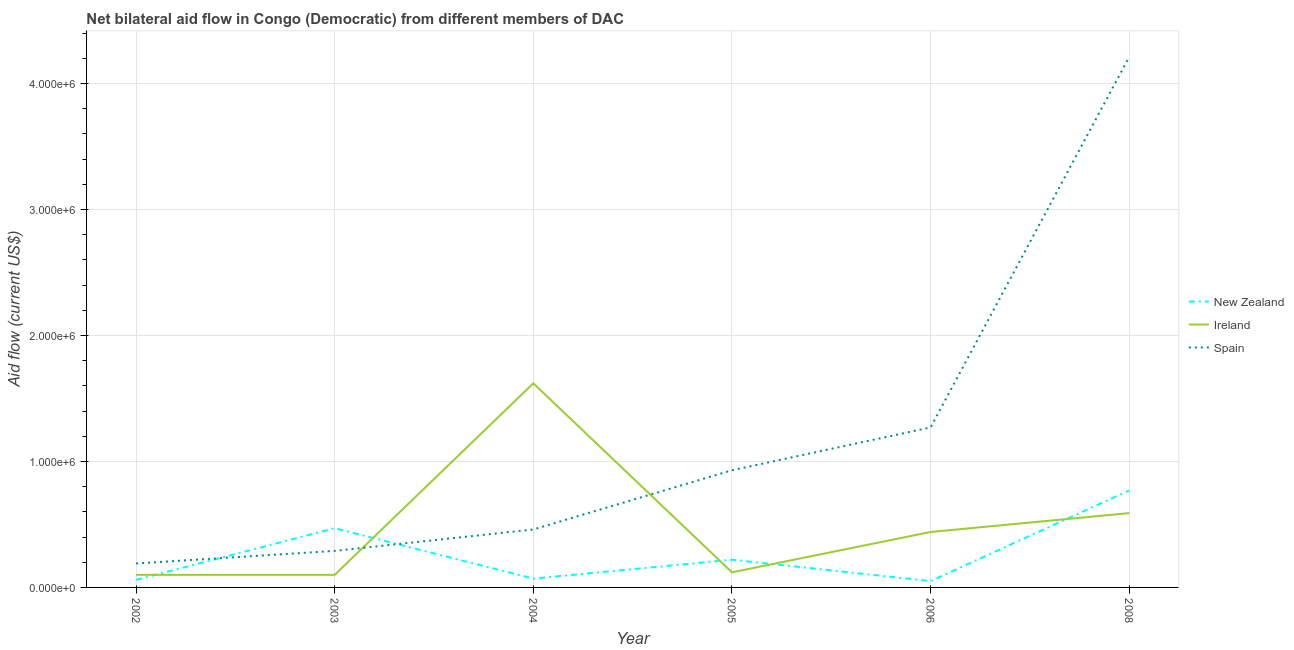Is the number of lines equal to the number of legend labels?
Your answer should be very brief. Yes. What is the amount of aid provided by ireland in 2006?
Offer a terse response. 4.40e+05. Across all years, what is the maximum amount of aid provided by ireland?
Provide a succinct answer. 1.62e+06. Across all years, what is the minimum amount of aid provided by spain?
Your answer should be compact. 1.90e+05. In which year was the amount of aid provided by spain maximum?
Provide a short and direct response. 2008. In which year was the amount of aid provided by spain minimum?
Keep it short and to the point. 2002. What is the total amount of aid provided by spain in the graph?
Your answer should be very brief. 7.35e+06. What is the difference between the amount of aid provided by ireland in 2002 and that in 2003?
Offer a very short reply. 0. What is the difference between the amount of aid provided by ireland in 2005 and the amount of aid provided by new zealand in 2003?
Provide a short and direct response. -3.50e+05. What is the average amount of aid provided by new zealand per year?
Your response must be concise. 2.73e+05. In the year 2002, what is the difference between the amount of aid provided by spain and amount of aid provided by ireland?
Keep it short and to the point. 9.00e+04. What is the ratio of the amount of aid provided by new zealand in 2002 to that in 2004?
Make the answer very short. 0.86. Is the amount of aid provided by ireland in 2004 less than that in 2008?
Give a very brief answer. No. Is the difference between the amount of aid provided by new zealand in 2003 and 2006 greater than the difference between the amount of aid provided by ireland in 2003 and 2006?
Your answer should be very brief. Yes. What is the difference between the highest and the second highest amount of aid provided by ireland?
Your response must be concise. 1.03e+06. What is the difference between the highest and the lowest amount of aid provided by spain?
Your answer should be very brief. 4.02e+06. Is the sum of the amount of aid provided by new zealand in 2005 and 2008 greater than the maximum amount of aid provided by spain across all years?
Offer a terse response. No. Is it the case that in every year, the sum of the amount of aid provided by new zealand and amount of aid provided by ireland is greater than the amount of aid provided by spain?
Offer a very short reply. No. Does the amount of aid provided by spain monotonically increase over the years?
Your response must be concise. Yes. Is the amount of aid provided by spain strictly less than the amount of aid provided by ireland over the years?
Your answer should be compact. No. How many years are there in the graph?
Make the answer very short. 6. What is the difference between two consecutive major ticks on the Y-axis?
Your answer should be very brief. 1.00e+06. Does the graph contain grids?
Your answer should be very brief. Yes. What is the title of the graph?
Provide a short and direct response. Net bilateral aid flow in Congo (Democratic) from different members of DAC. Does "Ages 50+" appear as one of the legend labels in the graph?
Your answer should be very brief. No. What is the label or title of the X-axis?
Give a very brief answer. Year. What is the label or title of the Y-axis?
Make the answer very short. Aid flow (current US$). What is the Aid flow (current US$) in New Zealand in 2002?
Provide a succinct answer. 6.00e+04. What is the Aid flow (current US$) of Ireland in 2002?
Provide a succinct answer. 1.00e+05. What is the Aid flow (current US$) of New Zealand in 2003?
Your answer should be very brief. 4.70e+05. What is the Aid flow (current US$) in Ireland in 2003?
Ensure brevity in your answer.  1.00e+05. What is the Aid flow (current US$) of Spain in 2003?
Provide a short and direct response. 2.90e+05. What is the Aid flow (current US$) of Ireland in 2004?
Your answer should be compact. 1.62e+06. What is the Aid flow (current US$) of Spain in 2005?
Your response must be concise. 9.30e+05. What is the Aid flow (current US$) of Spain in 2006?
Offer a very short reply. 1.27e+06. What is the Aid flow (current US$) of New Zealand in 2008?
Offer a very short reply. 7.70e+05. What is the Aid flow (current US$) in Ireland in 2008?
Your response must be concise. 5.90e+05. What is the Aid flow (current US$) of Spain in 2008?
Provide a short and direct response. 4.21e+06. Across all years, what is the maximum Aid flow (current US$) in New Zealand?
Offer a terse response. 7.70e+05. Across all years, what is the maximum Aid flow (current US$) of Ireland?
Your answer should be compact. 1.62e+06. Across all years, what is the maximum Aid flow (current US$) of Spain?
Ensure brevity in your answer.  4.21e+06. Across all years, what is the minimum Aid flow (current US$) of New Zealand?
Give a very brief answer. 5.00e+04. Across all years, what is the minimum Aid flow (current US$) in Ireland?
Your answer should be very brief. 1.00e+05. What is the total Aid flow (current US$) in New Zealand in the graph?
Ensure brevity in your answer.  1.64e+06. What is the total Aid flow (current US$) in Ireland in the graph?
Your answer should be compact. 2.97e+06. What is the total Aid flow (current US$) of Spain in the graph?
Provide a short and direct response. 7.35e+06. What is the difference between the Aid flow (current US$) of New Zealand in 2002 and that in 2003?
Give a very brief answer. -4.10e+05. What is the difference between the Aid flow (current US$) of Ireland in 2002 and that in 2003?
Your response must be concise. 0. What is the difference between the Aid flow (current US$) of Spain in 2002 and that in 2003?
Keep it short and to the point. -1.00e+05. What is the difference between the Aid flow (current US$) in New Zealand in 2002 and that in 2004?
Offer a very short reply. -10000. What is the difference between the Aid flow (current US$) of Ireland in 2002 and that in 2004?
Keep it short and to the point. -1.52e+06. What is the difference between the Aid flow (current US$) of New Zealand in 2002 and that in 2005?
Offer a very short reply. -1.60e+05. What is the difference between the Aid flow (current US$) of Spain in 2002 and that in 2005?
Your response must be concise. -7.40e+05. What is the difference between the Aid flow (current US$) in New Zealand in 2002 and that in 2006?
Your answer should be very brief. 10000. What is the difference between the Aid flow (current US$) in Ireland in 2002 and that in 2006?
Your answer should be very brief. -3.40e+05. What is the difference between the Aid flow (current US$) of Spain in 2002 and that in 2006?
Provide a short and direct response. -1.08e+06. What is the difference between the Aid flow (current US$) in New Zealand in 2002 and that in 2008?
Provide a succinct answer. -7.10e+05. What is the difference between the Aid flow (current US$) in Ireland in 2002 and that in 2008?
Your response must be concise. -4.90e+05. What is the difference between the Aid flow (current US$) of Spain in 2002 and that in 2008?
Your answer should be compact. -4.02e+06. What is the difference between the Aid flow (current US$) in New Zealand in 2003 and that in 2004?
Your answer should be very brief. 4.00e+05. What is the difference between the Aid flow (current US$) in Ireland in 2003 and that in 2004?
Ensure brevity in your answer.  -1.52e+06. What is the difference between the Aid flow (current US$) in New Zealand in 2003 and that in 2005?
Keep it short and to the point. 2.50e+05. What is the difference between the Aid flow (current US$) in Spain in 2003 and that in 2005?
Your answer should be very brief. -6.40e+05. What is the difference between the Aid flow (current US$) in New Zealand in 2003 and that in 2006?
Keep it short and to the point. 4.20e+05. What is the difference between the Aid flow (current US$) of Ireland in 2003 and that in 2006?
Your answer should be compact. -3.40e+05. What is the difference between the Aid flow (current US$) of Spain in 2003 and that in 2006?
Offer a terse response. -9.80e+05. What is the difference between the Aid flow (current US$) in New Zealand in 2003 and that in 2008?
Your response must be concise. -3.00e+05. What is the difference between the Aid flow (current US$) in Ireland in 2003 and that in 2008?
Your answer should be very brief. -4.90e+05. What is the difference between the Aid flow (current US$) of Spain in 2003 and that in 2008?
Ensure brevity in your answer.  -3.92e+06. What is the difference between the Aid flow (current US$) in New Zealand in 2004 and that in 2005?
Make the answer very short. -1.50e+05. What is the difference between the Aid flow (current US$) of Ireland in 2004 and that in 2005?
Ensure brevity in your answer.  1.50e+06. What is the difference between the Aid flow (current US$) in Spain in 2004 and that in 2005?
Provide a succinct answer. -4.70e+05. What is the difference between the Aid flow (current US$) in New Zealand in 2004 and that in 2006?
Ensure brevity in your answer.  2.00e+04. What is the difference between the Aid flow (current US$) of Ireland in 2004 and that in 2006?
Offer a very short reply. 1.18e+06. What is the difference between the Aid flow (current US$) in Spain in 2004 and that in 2006?
Offer a terse response. -8.10e+05. What is the difference between the Aid flow (current US$) of New Zealand in 2004 and that in 2008?
Your response must be concise. -7.00e+05. What is the difference between the Aid flow (current US$) of Ireland in 2004 and that in 2008?
Your response must be concise. 1.03e+06. What is the difference between the Aid flow (current US$) in Spain in 2004 and that in 2008?
Ensure brevity in your answer.  -3.75e+06. What is the difference between the Aid flow (current US$) in New Zealand in 2005 and that in 2006?
Offer a terse response. 1.70e+05. What is the difference between the Aid flow (current US$) of Ireland in 2005 and that in 2006?
Make the answer very short. -3.20e+05. What is the difference between the Aid flow (current US$) in New Zealand in 2005 and that in 2008?
Give a very brief answer. -5.50e+05. What is the difference between the Aid flow (current US$) in Ireland in 2005 and that in 2008?
Give a very brief answer. -4.70e+05. What is the difference between the Aid flow (current US$) in Spain in 2005 and that in 2008?
Provide a succinct answer. -3.28e+06. What is the difference between the Aid flow (current US$) of New Zealand in 2006 and that in 2008?
Your response must be concise. -7.20e+05. What is the difference between the Aid flow (current US$) in Spain in 2006 and that in 2008?
Your response must be concise. -2.94e+06. What is the difference between the Aid flow (current US$) of New Zealand in 2002 and the Aid flow (current US$) of Ireland in 2003?
Make the answer very short. -4.00e+04. What is the difference between the Aid flow (current US$) of Ireland in 2002 and the Aid flow (current US$) of Spain in 2003?
Provide a succinct answer. -1.90e+05. What is the difference between the Aid flow (current US$) of New Zealand in 2002 and the Aid flow (current US$) of Ireland in 2004?
Provide a short and direct response. -1.56e+06. What is the difference between the Aid flow (current US$) in New Zealand in 2002 and the Aid flow (current US$) in Spain in 2004?
Offer a very short reply. -4.00e+05. What is the difference between the Aid flow (current US$) in Ireland in 2002 and the Aid flow (current US$) in Spain in 2004?
Offer a very short reply. -3.60e+05. What is the difference between the Aid flow (current US$) of New Zealand in 2002 and the Aid flow (current US$) of Ireland in 2005?
Your answer should be very brief. -6.00e+04. What is the difference between the Aid flow (current US$) in New Zealand in 2002 and the Aid flow (current US$) in Spain in 2005?
Give a very brief answer. -8.70e+05. What is the difference between the Aid flow (current US$) in Ireland in 2002 and the Aid flow (current US$) in Spain in 2005?
Give a very brief answer. -8.30e+05. What is the difference between the Aid flow (current US$) of New Zealand in 2002 and the Aid flow (current US$) of Ireland in 2006?
Provide a short and direct response. -3.80e+05. What is the difference between the Aid flow (current US$) in New Zealand in 2002 and the Aid flow (current US$) in Spain in 2006?
Your answer should be very brief. -1.21e+06. What is the difference between the Aid flow (current US$) of Ireland in 2002 and the Aid flow (current US$) of Spain in 2006?
Your answer should be very brief. -1.17e+06. What is the difference between the Aid flow (current US$) of New Zealand in 2002 and the Aid flow (current US$) of Ireland in 2008?
Give a very brief answer. -5.30e+05. What is the difference between the Aid flow (current US$) in New Zealand in 2002 and the Aid flow (current US$) in Spain in 2008?
Offer a terse response. -4.15e+06. What is the difference between the Aid flow (current US$) of Ireland in 2002 and the Aid flow (current US$) of Spain in 2008?
Keep it short and to the point. -4.11e+06. What is the difference between the Aid flow (current US$) in New Zealand in 2003 and the Aid flow (current US$) in Ireland in 2004?
Offer a very short reply. -1.15e+06. What is the difference between the Aid flow (current US$) of New Zealand in 2003 and the Aid flow (current US$) of Spain in 2004?
Offer a very short reply. 10000. What is the difference between the Aid flow (current US$) in Ireland in 2003 and the Aid flow (current US$) in Spain in 2004?
Provide a succinct answer. -3.60e+05. What is the difference between the Aid flow (current US$) in New Zealand in 2003 and the Aid flow (current US$) in Ireland in 2005?
Make the answer very short. 3.50e+05. What is the difference between the Aid flow (current US$) in New Zealand in 2003 and the Aid flow (current US$) in Spain in 2005?
Offer a terse response. -4.60e+05. What is the difference between the Aid flow (current US$) of Ireland in 2003 and the Aid flow (current US$) of Spain in 2005?
Your answer should be compact. -8.30e+05. What is the difference between the Aid flow (current US$) in New Zealand in 2003 and the Aid flow (current US$) in Spain in 2006?
Provide a short and direct response. -8.00e+05. What is the difference between the Aid flow (current US$) in Ireland in 2003 and the Aid flow (current US$) in Spain in 2006?
Your response must be concise. -1.17e+06. What is the difference between the Aid flow (current US$) of New Zealand in 2003 and the Aid flow (current US$) of Ireland in 2008?
Ensure brevity in your answer.  -1.20e+05. What is the difference between the Aid flow (current US$) in New Zealand in 2003 and the Aid flow (current US$) in Spain in 2008?
Offer a terse response. -3.74e+06. What is the difference between the Aid flow (current US$) of Ireland in 2003 and the Aid flow (current US$) of Spain in 2008?
Your answer should be compact. -4.11e+06. What is the difference between the Aid flow (current US$) in New Zealand in 2004 and the Aid flow (current US$) in Ireland in 2005?
Your response must be concise. -5.00e+04. What is the difference between the Aid flow (current US$) in New Zealand in 2004 and the Aid flow (current US$) in Spain in 2005?
Provide a short and direct response. -8.60e+05. What is the difference between the Aid flow (current US$) in Ireland in 2004 and the Aid flow (current US$) in Spain in 2005?
Ensure brevity in your answer.  6.90e+05. What is the difference between the Aid flow (current US$) in New Zealand in 2004 and the Aid flow (current US$) in Ireland in 2006?
Ensure brevity in your answer.  -3.70e+05. What is the difference between the Aid flow (current US$) of New Zealand in 2004 and the Aid flow (current US$) of Spain in 2006?
Offer a terse response. -1.20e+06. What is the difference between the Aid flow (current US$) in New Zealand in 2004 and the Aid flow (current US$) in Ireland in 2008?
Offer a very short reply. -5.20e+05. What is the difference between the Aid flow (current US$) in New Zealand in 2004 and the Aid flow (current US$) in Spain in 2008?
Make the answer very short. -4.14e+06. What is the difference between the Aid flow (current US$) of Ireland in 2004 and the Aid flow (current US$) of Spain in 2008?
Ensure brevity in your answer.  -2.59e+06. What is the difference between the Aid flow (current US$) of New Zealand in 2005 and the Aid flow (current US$) of Spain in 2006?
Make the answer very short. -1.05e+06. What is the difference between the Aid flow (current US$) in Ireland in 2005 and the Aid flow (current US$) in Spain in 2006?
Provide a succinct answer. -1.15e+06. What is the difference between the Aid flow (current US$) of New Zealand in 2005 and the Aid flow (current US$) of Ireland in 2008?
Your response must be concise. -3.70e+05. What is the difference between the Aid flow (current US$) of New Zealand in 2005 and the Aid flow (current US$) of Spain in 2008?
Your response must be concise. -3.99e+06. What is the difference between the Aid flow (current US$) of Ireland in 2005 and the Aid flow (current US$) of Spain in 2008?
Offer a very short reply. -4.09e+06. What is the difference between the Aid flow (current US$) of New Zealand in 2006 and the Aid flow (current US$) of Ireland in 2008?
Offer a terse response. -5.40e+05. What is the difference between the Aid flow (current US$) of New Zealand in 2006 and the Aid flow (current US$) of Spain in 2008?
Provide a succinct answer. -4.16e+06. What is the difference between the Aid flow (current US$) of Ireland in 2006 and the Aid flow (current US$) of Spain in 2008?
Your answer should be very brief. -3.77e+06. What is the average Aid flow (current US$) of New Zealand per year?
Your answer should be very brief. 2.73e+05. What is the average Aid flow (current US$) of Ireland per year?
Provide a succinct answer. 4.95e+05. What is the average Aid flow (current US$) of Spain per year?
Your response must be concise. 1.22e+06. In the year 2002, what is the difference between the Aid flow (current US$) of New Zealand and Aid flow (current US$) of Ireland?
Your response must be concise. -4.00e+04. In the year 2003, what is the difference between the Aid flow (current US$) in New Zealand and Aid flow (current US$) in Ireland?
Your response must be concise. 3.70e+05. In the year 2003, what is the difference between the Aid flow (current US$) in New Zealand and Aid flow (current US$) in Spain?
Make the answer very short. 1.80e+05. In the year 2003, what is the difference between the Aid flow (current US$) of Ireland and Aid flow (current US$) of Spain?
Provide a short and direct response. -1.90e+05. In the year 2004, what is the difference between the Aid flow (current US$) of New Zealand and Aid flow (current US$) of Ireland?
Offer a very short reply. -1.55e+06. In the year 2004, what is the difference between the Aid flow (current US$) in New Zealand and Aid flow (current US$) in Spain?
Provide a short and direct response. -3.90e+05. In the year 2004, what is the difference between the Aid flow (current US$) in Ireland and Aid flow (current US$) in Spain?
Your answer should be compact. 1.16e+06. In the year 2005, what is the difference between the Aid flow (current US$) in New Zealand and Aid flow (current US$) in Spain?
Make the answer very short. -7.10e+05. In the year 2005, what is the difference between the Aid flow (current US$) of Ireland and Aid flow (current US$) of Spain?
Give a very brief answer. -8.10e+05. In the year 2006, what is the difference between the Aid flow (current US$) of New Zealand and Aid flow (current US$) of Ireland?
Offer a very short reply. -3.90e+05. In the year 2006, what is the difference between the Aid flow (current US$) in New Zealand and Aid flow (current US$) in Spain?
Keep it short and to the point. -1.22e+06. In the year 2006, what is the difference between the Aid flow (current US$) of Ireland and Aid flow (current US$) of Spain?
Ensure brevity in your answer.  -8.30e+05. In the year 2008, what is the difference between the Aid flow (current US$) in New Zealand and Aid flow (current US$) in Spain?
Your answer should be compact. -3.44e+06. In the year 2008, what is the difference between the Aid flow (current US$) of Ireland and Aid flow (current US$) of Spain?
Make the answer very short. -3.62e+06. What is the ratio of the Aid flow (current US$) of New Zealand in 2002 to that in 2003?
Your answer should be very brief. 0.13. What is the ratio of the Aid flow (current US$) in Ireland in 2002 to that in 2003?
Your response must be concise. 1. What is the ratio of the Aid flow (current US$) of Spain in 2002 to that in 2003?
Make the answer very short. 0.66. What is the ratio of the Aid flow (current US$) in Ireland in 2002 to that in 2004?
Your answer should be compact. 0.06. What is the ratio of the Aid flow (current US$) in Spain in 2002 to that in 2004?
Your answer should be compact. 0.41. What is the ratio of the Aid flow (current US$) of New Zealand in 2002 to that in 2005?
Provide a succinct answer. 0.27. What is the ratio of the Aid flow (current US$) in Spain in 2002 to that in 2005?
Offer a terse response. 0.2. What is the ratio of the Aid flow (current US$) in Ireland in 2002 to that in 2006?
Make the answer very short. 0.23. What is the ratio of the Aid flow (current US$) of Spain in 2002 to that in 2006?
Your response must be concise. 0.15. What is the ratio of the Aid flow (current US$) of New Zealand in 2002 to that in 2008?
Ensure brevity in your answer.  0.08. What is the ratio of the Aid flow (current US$) in Ireland in 2002 to that in 2008?
Provide a succinct answer. 0.17. What is the ratio of the Aid flow (current US$) in Spain in 2002 to that in 2008?
Offer a very short reply. 0.05. What is the ratio of the Aid flow (current US$) in New Zealand in 2003 to that in 2004?
Your answer should be compact. 6.71. What is the ratio of the Aid flow (current US$) in Ireland in 2003 to that in 2004?
Your answer should be very brief. 0.06. What is the ratio of the Aid flow (current US$) in Spain in 2003 to that in 2004?
Offer a very short reply. 0.63. What is the ratio of the Aid flow (current US$) in New Zealand in 2003 to that in 2005?
Provide a short and direct response. 2.14. What is the ratio of the Aid flow (current US$) in Ireland in 2003 to that in 2005?
Your response must be concise. 0.83. What is the ratio of the Aid flow (current US$) of Spain in 2003 to that in 2005?
Keep it short and to the point. 0.31. What is the ratio of the Aid flow (current US$) in New Zealand in 2003 to that in 2006?
Your answer should be very brief. 9.4. What is the ratio of the Aid flow (current US$) in Ireland in 2003 to that in 2006?
Provide a succinct answer. 0.23. What is the ratio of the Aid flow (current US$) in Spain in 2003 to that in 2006?
Your answer should be compact. 0.23. What is the ratio of the Aid flow (current US$) in New Zealand in 2003 to that in 2008?
Offer a terse response. 0.61. What is the ratio of the Aid flow (current US$) of Ireland in 2003 to that in 2008?
Provide a short and direct response. 0.17. What is the ratio of the Aid flow (current US$) of Spain in 2003 to that in 2008?
Keep it short and to the point. 0.07. What is the ratio of the Aid flow (current US$) in New Zealand in 2004 to that in 2005?
Your answer should be compact. 0.32. What is the ratio of the Aid flow (current US$) in Spain in 2004 to that in 2005?
Provide a succinct answer. 0.49. What is the ratio of the Aid flow (current US$) of New Zealand in 2004 to that in 2006?
Ensure brevity in your answer.  1.4. What is the ratio of the Aid flow (current US$) in Ireland in 2004 to that in 2006?
Offer a very short reply. 3.68. What is the ratio of the Aid flow (current US$) in Spain in 2004 to that in 2006?
Offer a very short reply. 0.36. What is the ratio of the Aid flow (current US$) of New Zealand in 2004 to that in 2008?
Offer a very short reply. 0.09. What is the ratio of the Aid flow (current US$) of Ireland in 2004 to that in 2008?
Provide a short and direct response. 2.75. What is the ratio of the Aid flow (current US$) in Spain in 2004 to that in 2008?
Your answer should be compact. 0.11. What is the ratio of the Aid flow (current US$) in Ireland in 2005 to that in 2006?
Your answer should be very brief. 0.27. What is the ratio of the Aid flow (current US$) in Spain in 2005 to that in 2006?
Ensure brevity in your answer.  0.73. What is the ratio of the Aid flow (current US$) of New Zealand in 2005 to that in 2008?
Keep it short and to the point. 0.29. What is the ratio of the Aid flow (current US$) of Ireland in 2005 to that in 2008?
Provide a short and direct response. 0.2. What is the ratio of the Aid flow (current US$) of Spain in 2005 to that in 2008?
Provide a succinct answer. 0.22. What is the ratio of the Aid flow (current US$) in New Zealand in 2006 to that in 2008?
Make the answer very short. 0.06. What is the ratio of the Aid flow (current US$) of Ireland in 2006 to that in 2008?
Your answer should be very brief. 0.75. What is the ratio of the Aid flow (current US$) in Spain in 2006 to that in 2008?
Your answer should be very brief. 0.3. What is the difference between the highest and the second highest Aid flow (current US$) of Ireland?
Keep it short and to the point. 1.03e+06. What is the difference between the highest and the second highest Aid flow (current US$) of Spain?
Your response must be concise. 2.94e+06. What is the difference between the highest and the lowest Aid flow (current US$) of New Zealand?
Provide a short and direct response. 7.20e+05. What is the difference between the highest and the lowest Aid flow (current US$) in Ireland?
Offer a terse response. 1.52e+06. What is the difference between the highest and the lowest Aid flow (current US$) in Spain?
Give a very brief answer. 4.02e+06. 